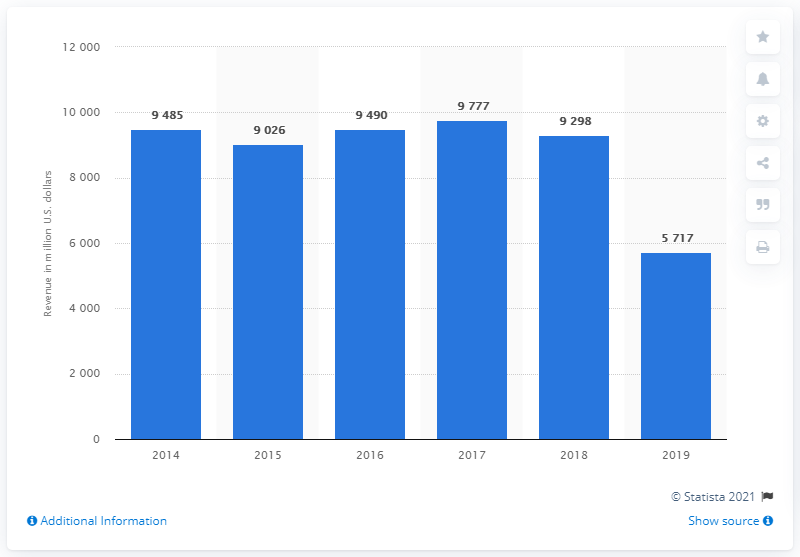Indicate a few pertinent items in this graphic. In the fiscal year 2019, Honeywell Building Technologies generated a total revenue of $571.7 million. 